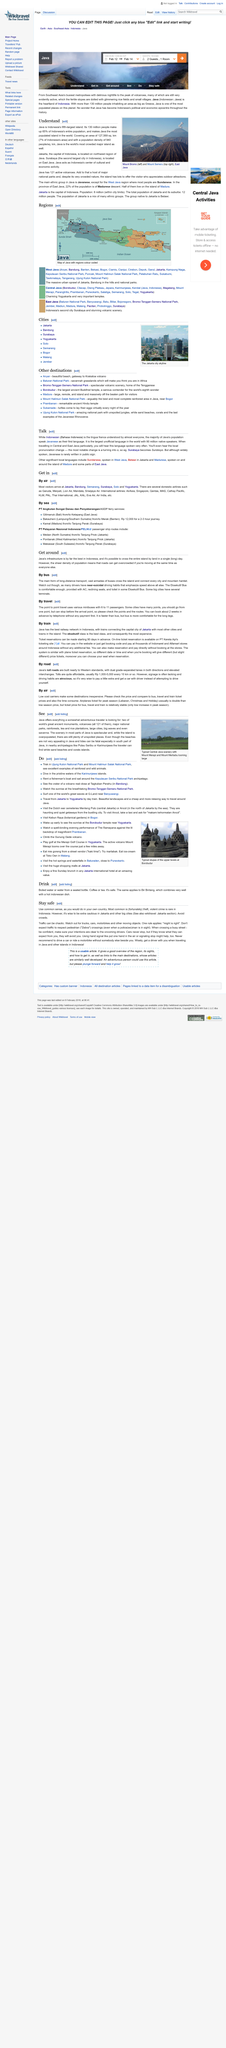Point out several critical features in this image. Java has 121 mountains, and it is known to have a significant number of volcanoes. Java has 121 active volcanos. Violent crime is not a common occurrence in Indonesia, as it is relatively rare. The main form of long distance transport across Indonesia is by bus. Surabaya is the second largest city in Indonesia, following the capital, Jakarta. 